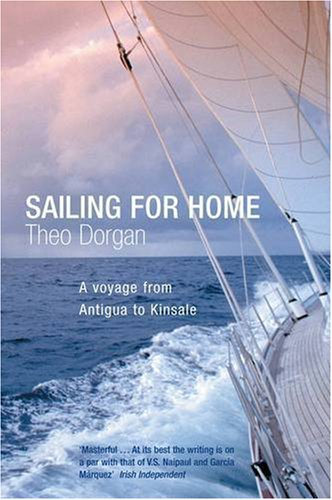What is the title of this book? 'Sailing For Home' is the title of this intriguing travel narrative by Theo Dorgan, highlighting a personal voyage from Antigua to Kinsale. 